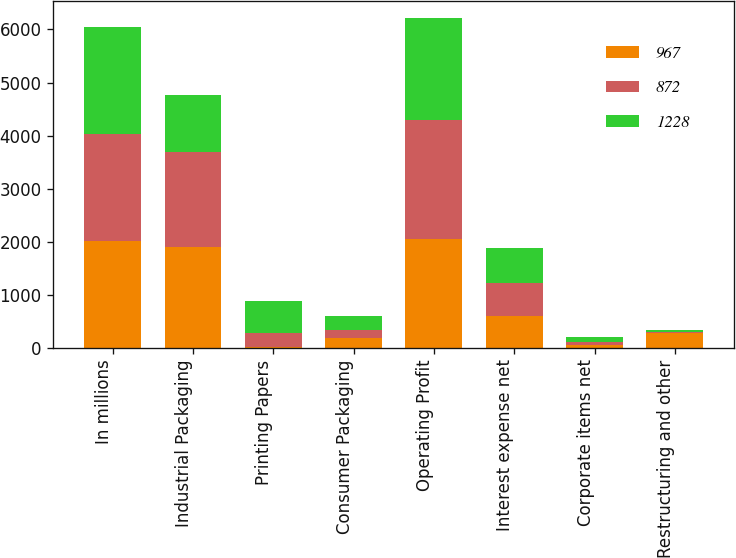Convert chart. <chart><loc_0><loc_0><loc_500><loc_500><stacked_bar_chart><ecel><fcel>In millions<fcel>Industrial Packaging<fcel>Printing Papers<fcel>Consumer Packaging<fcel>Operating Profit<fcel>Interest expense net<fcel>Corporate items net<fcel>Restructuring and other<nl><fcel>967<fcel>2014<fcel>1896<fcel>16<fcel>178<fcel>2058<fcel>601<fcel>51<fcel>282<nl><fcel>872<fcel>2013<fcel>1801<fcel>271<fcel>161<fcel>2233<fcel>612<fcel>61<fcel>10<nl><fcel>1228<fcel>2012<fcel>1066<fcel>599<fcel>268<fcel>1933<fcel>671<fcel>87<fcel>51<nl></chart> 